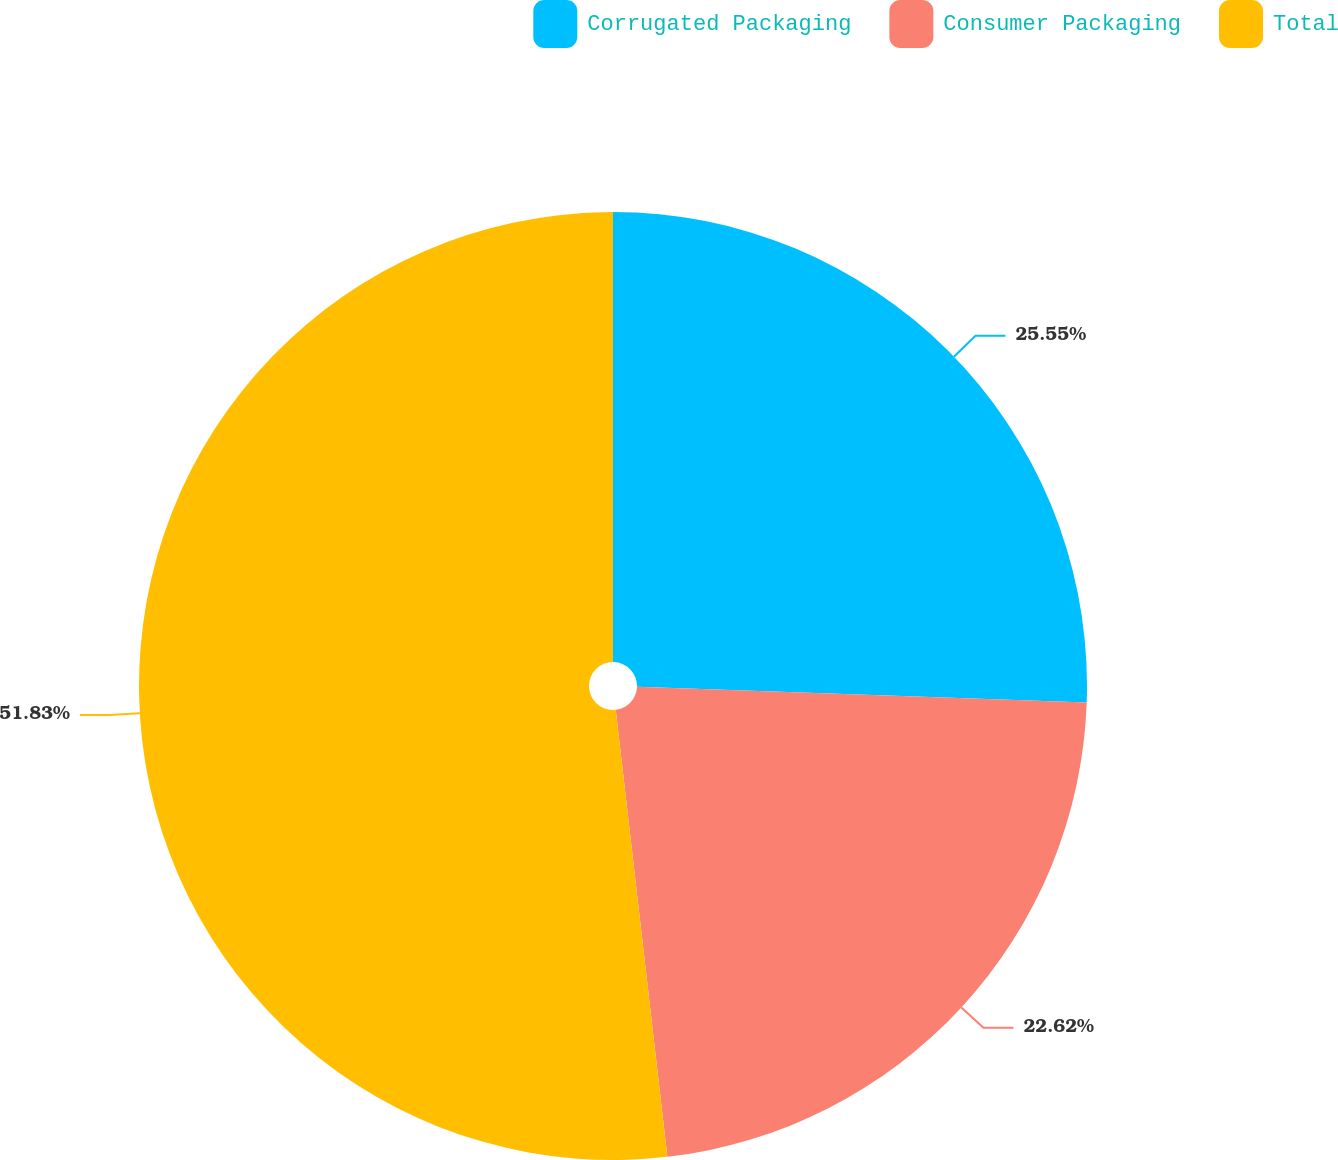<chart> <loc_0><loc_0><loc_500><loc_500><pie_chart><fcel>Corrugated Packaging<fcel>Consumer Packaging<fcel>Total<nl><fcel>25.55%<fcel>22.62%<fcel>51.83%<nl></chart> 